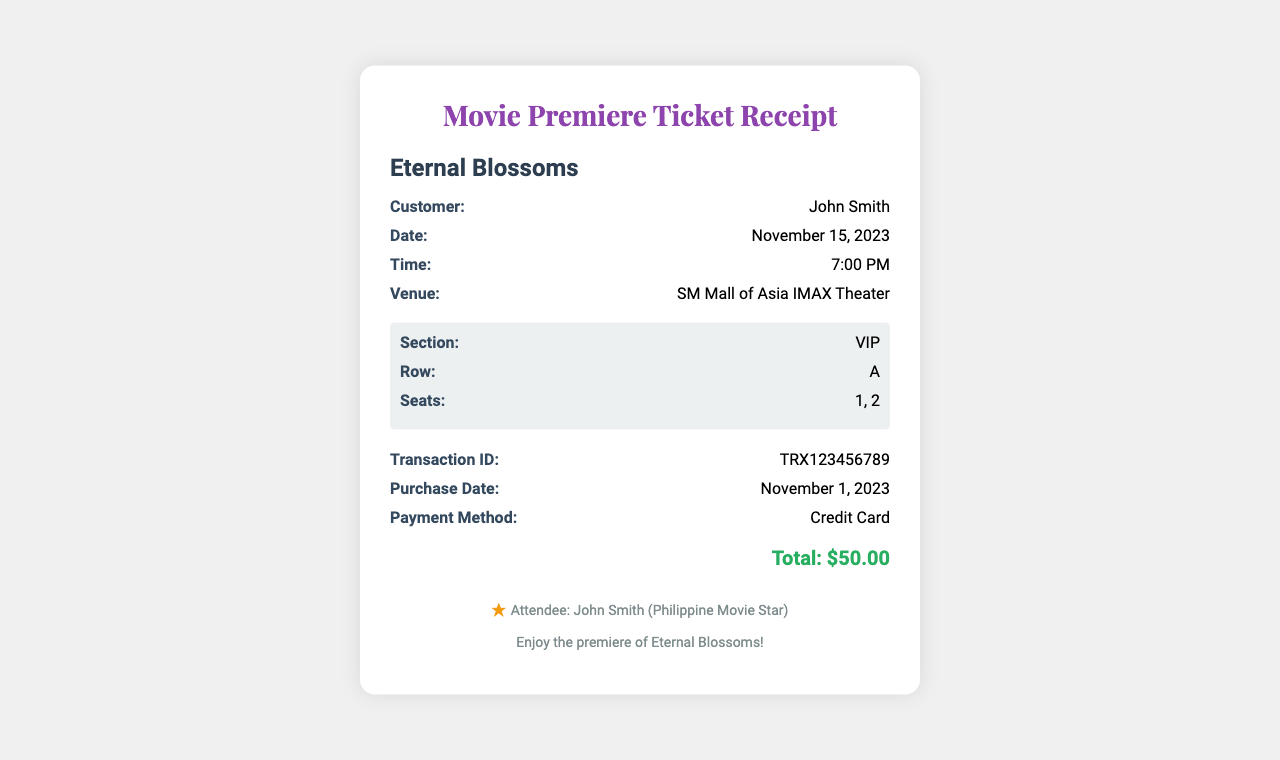what is the movie title? The movie title is prominently displayed in the document, which is "Eternal Blossoms."
Answer: Eternal Blossoms who is the customer? The customer's name is mentioned in the details section, which is "John Smith."
Answer: John Smith what is the transaction ID? The transaction ID is provided to identify the purchase, which is "TRX123456789."
Answer: TRX123456789 when is the premiere date? The premiere date is listed under the details section as "November 15, 2023."
Answer: November 15, 2023 how many seats were purchased? The seats purchased are listed as "1, 2," indicating that two seats were bought.
Answer: 2 what time is the movie scheduled? The time is specified in the document details, set to "7:00 PM."
Answer: 7:00 PM what section are the seats located in? The section of the seats is labeled as "VIP."
Answer: VIP what payment method was used? The payment method is noted in the details section as "Credit Card."
Answer: Credit Card who is the attendee? The attendee is indicated at the bottom of the document as "John Smith (Philippine Movie Star)."
Answer: John Smith (Philippine Movie Star) 